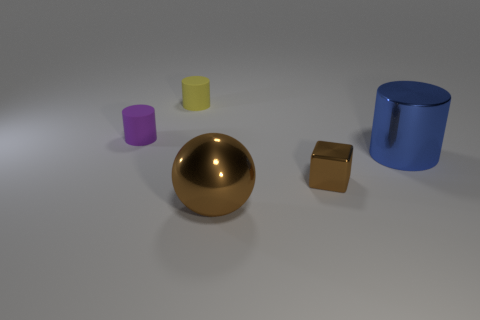How many other objects are there of the same size as the brown sphere?
Offer a very short reply. 1. There is a tiny object that is behind the tiny shiny thing and in front of the tiny yellow cylinder; what material is it?
Give a very brief answer. Rubber. What is the material of the small yellow object that is the same shape as the blue metal object?
Keep it short and to the point. Rubber. There is a cylinder that is to the right of the shiny object that is in front of the brown block; how many small brown objects are on the left side of it?
Ensure brevity in your answer.  1. Is there anything else that is the same color as the metal ball?
Your response must be concise. Yes. What number of metal objects are both in front of the big metallic cylinder and on the right side of the big brown metallic ball?
Make the answer very short. 1. Does the brown metallic thing that is behind the metallic ball have the same size as the cylinder that is on the right side of the big brown thing?
Give a very brief answer. No. How many things are either blue metallic things behind the metallic ball or big cyan cylinders?
Make the answer very short. 1. There is a brown object that is on the left side of the small block; what is it made of?
Provide a short and direct response. Metal. What is the big sphere made of?
Offer a terse response. Metal. 